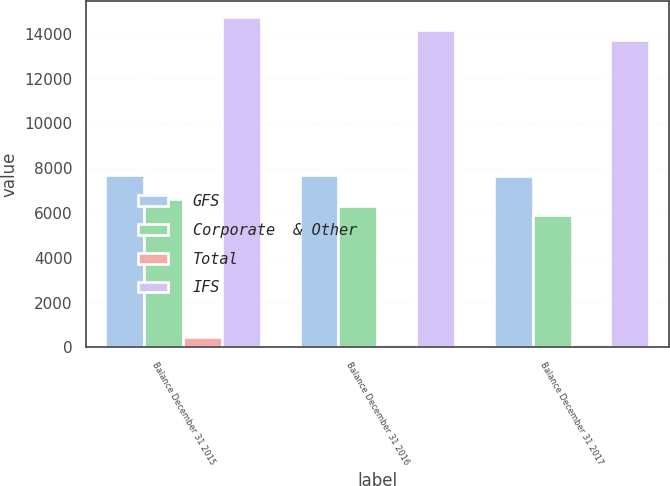<chart> <loc_0><loc_0><loc_500><loc_500><stacked_bar_chart><ecel><fcel>Balance December 31 2015<fcel>Balance December 31 2016<fcel>Balance December 31 2017<nl><fcel>GFS<fcel>7676<fcel>7676<fcel>7662<nl><fcel>Corporate  & Other<fcel>6605<fcel>6332<fcel>5898<nl><fcel>Total<fcel>464<fcel>170<fcel>170<nl><fcel>IFS<fcel>14745<fcel>14178<fcel>13730<nl></chart> 